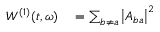Convert formula to latex. <formula><loc_0><loc_0><loc_500><loc_500>\begin{array} { r l } { W ^ { ( 1 ) } ( t , \omega ) } & = \sum _ { b \neq a } \left | A _ { b a } \right | ^ { 2 } } \end{array}</formula> 